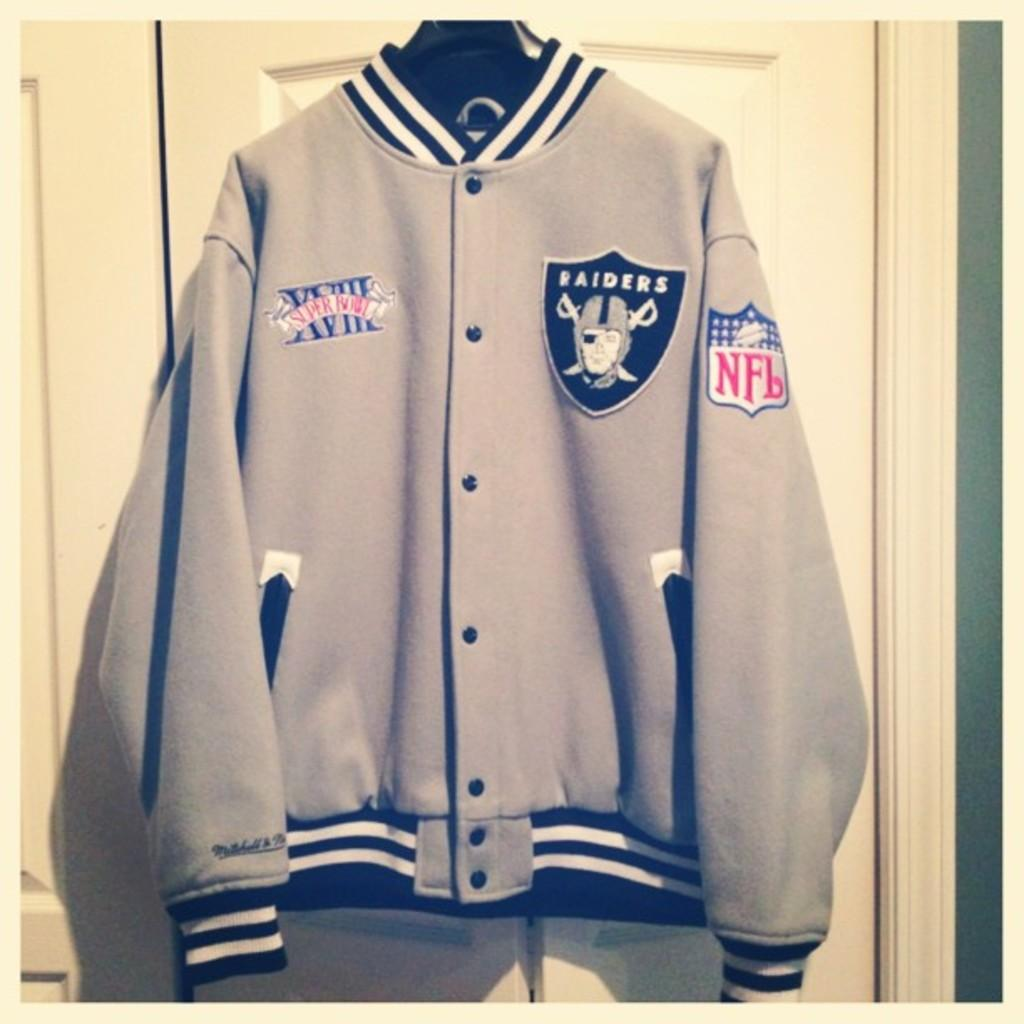Provide a one-sentence caption for the provided image. Gray jacket with a logo that says RAIDERS on it. 